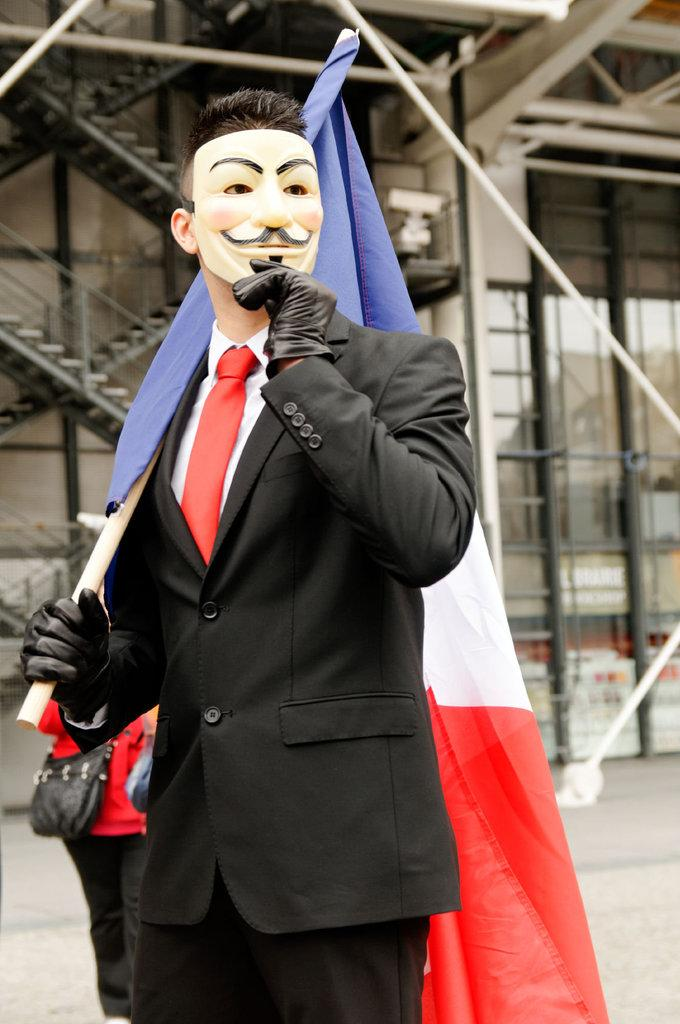How many people are in the image? There are people in the image, but the exact number is not specified. Can you describe the man in the middle of the image? The man in the middle of the image is wearing a mask and holding a flag. What is present in the background of the image? There are metal rods in the background of the image. What type of fish can be seen swimming near the man holding the flag? There are no fish present in the image; it features people and metal rods in the background. Can you describe the duck that is perched on the man's nose? There is no duck present in the image, and the man's nose is not mentioned in the facts. 